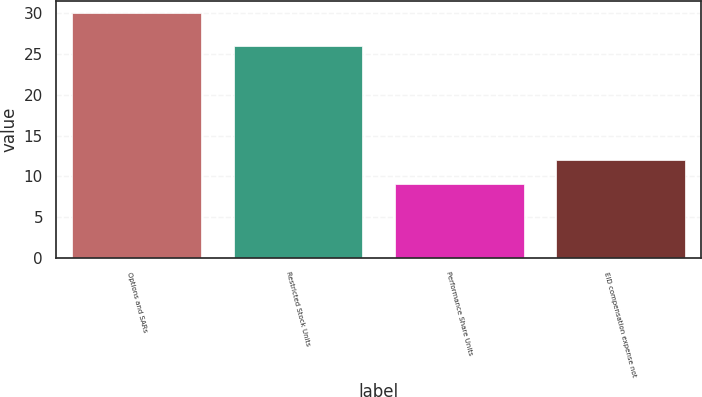Convert chart. <chart><loc_0><loc_0><loc_500><loc_500><bar_chart><fcel>Options and SARs<fcel>Restricted Stock Units<fcel>Performance Share Units<fcel>EID compensation expense not<nl><fcel>30<fcel>26<fcel>9<fcel>12<nl></chart> 